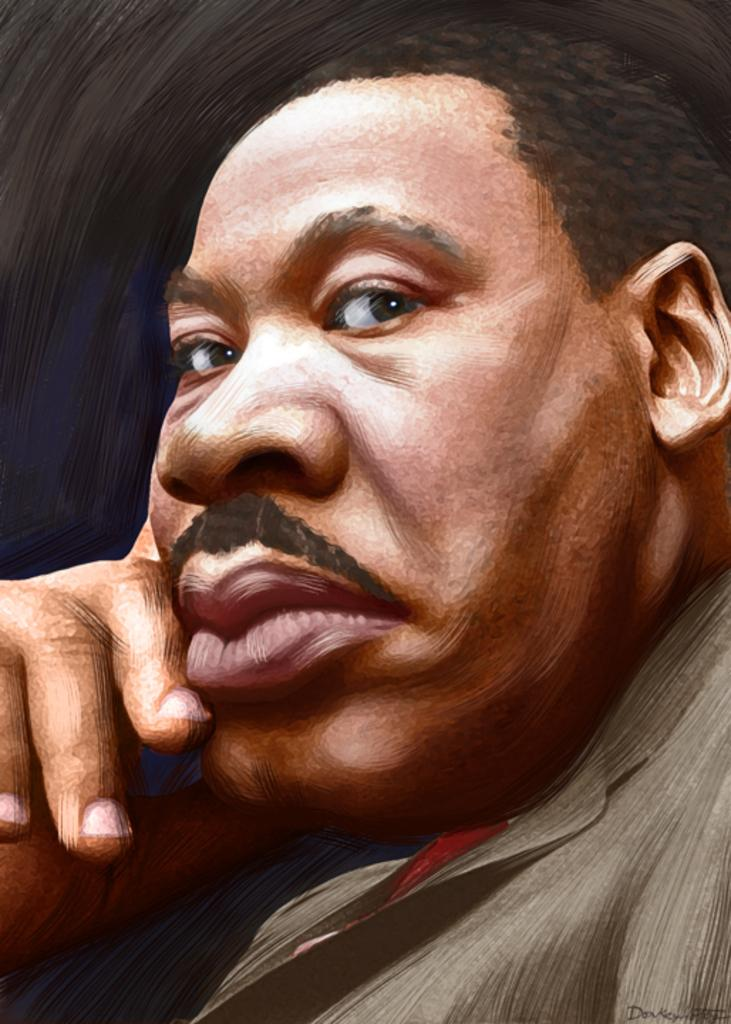What is the main subject of the image? There is a painting in the image. What is depicted in the painting? The painting depicts a man. What type of yarn is the man using in the painting? There is no yarn present in the painting; it depicts a man without any yarn. 